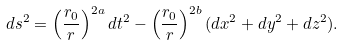<formula> <loc_0><loc_0><loc_500><loc_500>d s ^ { 2 } = \left ( \frac { r _ { 0 } } r \right ) ^ { 2 a } d t ^ { 2 } - \left ( \frac { r _ { 0 } } r \right ) ^ { 2 b } ( d x ^ { 2 } + d y ^ { 2 } + d z ^ { 2 } ) .</formula> 